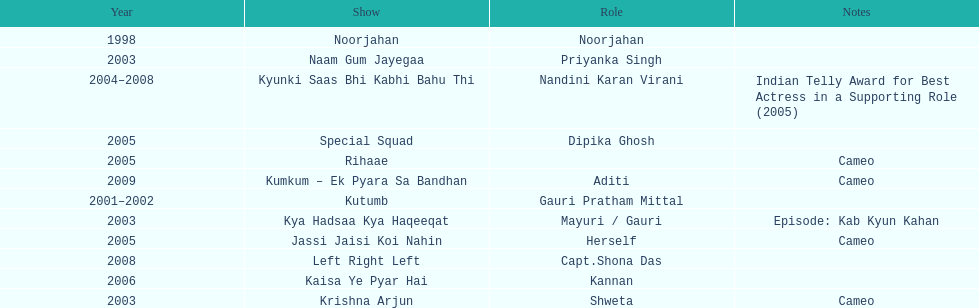How many shows were there in 2005? 3. 